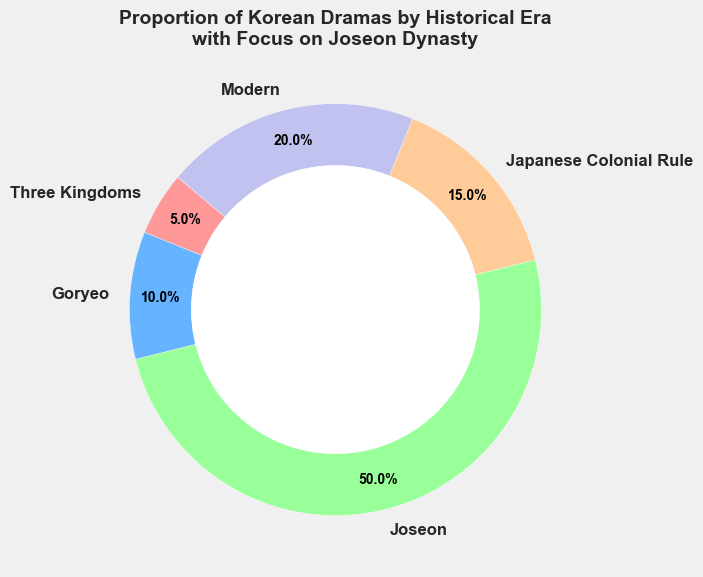What proportion of Korean dramas is set in the Joseon Era? Look at the segment labeled "Joseon" on the chart, which represents 50% of the total.
Answer: 50% How does the proportion of dramas set in the modern era compare to those set in the Goryeo period? The chart shows that the modern era is 20% while the Goryeo period is 10%. 20% is greater than 10%.
Answer: Modern era has a higher proportion What is the combined proportion of Korean dramas set during the Three Kingdoms and Japanese Colonial Rule eras? The chart shows the Three Kingdoms era at 5% and Japanese Colonial Rule at 15%. 5% + 15% = 20%.
Answer: 20% Compare the proportion of dramas set in the Joseon Era to those set in all other Eras combined. The chart shows the Joseon Era at 50%. The other eras combined sum to 5% + 10% + 15% + 20% = 50%.
Answer: They are equal Which era has the smallest proportion of Korean dramas? The chart shows that the Three Kingdoms period has the smallest proportion at 5%.
Answer: Three Kingdoms By how much does the proportion of dramas set in the Joseon Era exceed those set in the Japanese Colonial Rule period? The chart shows Joseon at 50% and Japanese Colonial Rule at 15%. 50% - 15% = 35%.
Answer: 35% Identify the era with the largest proportion of dramas and provide its proportion. The chart indicates the Joseon era is the largest with 50%.
Answer: Joseon, 50% What proportion of Korean dramas is neither in the Joseon Era nor the Modern era? The chart shows Joseon at 50% and Modern at 20%. The total is 50% + 20% = 70%. So, 100% - 70% = 30%.
Answer: 30% Is the proportion of dramas in the Goryeo era greater than or less than 3 times those in the Three Kingdoms era? The Goryeo era is at 10% and the Three Kingdoms at 5%. Three times 5% is 15%, which is greater than 10%.
Answer: Less than What visual feature in the chart indicates that the modern era is proportionally significant? The modern era section is visibly large, labeled at 20%, and distinctly colored.
Answer: Large section, 20% 